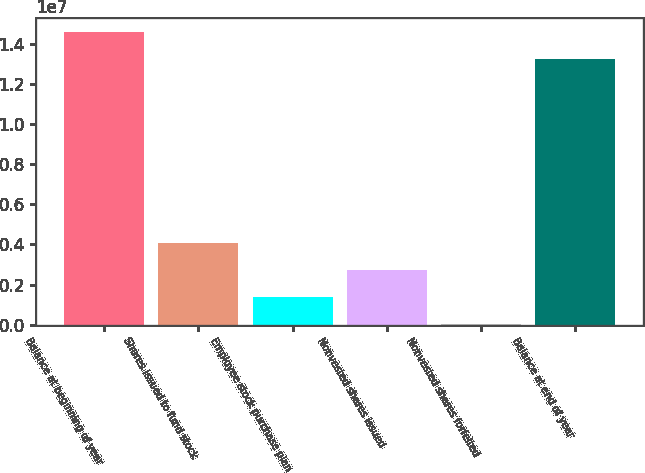<chart> <loc_0><loc_0><loc_500><loc_500><bar_chart><fcel>Balance at beginning of year<fcel>Shares issued to fund stock<fcel>Employee stock purchase plan<fcel>Nonvested shares issued<fcel>Nonvested shares forfeited<fcel>Balance at end of year<nl><fcel>1.45628e+07<fcel>4.04758e+06<fcel>1.36365e+06<fcel>2.70562e+06<fcel>21687<fcel>1.32208e+07<nl></chart> 